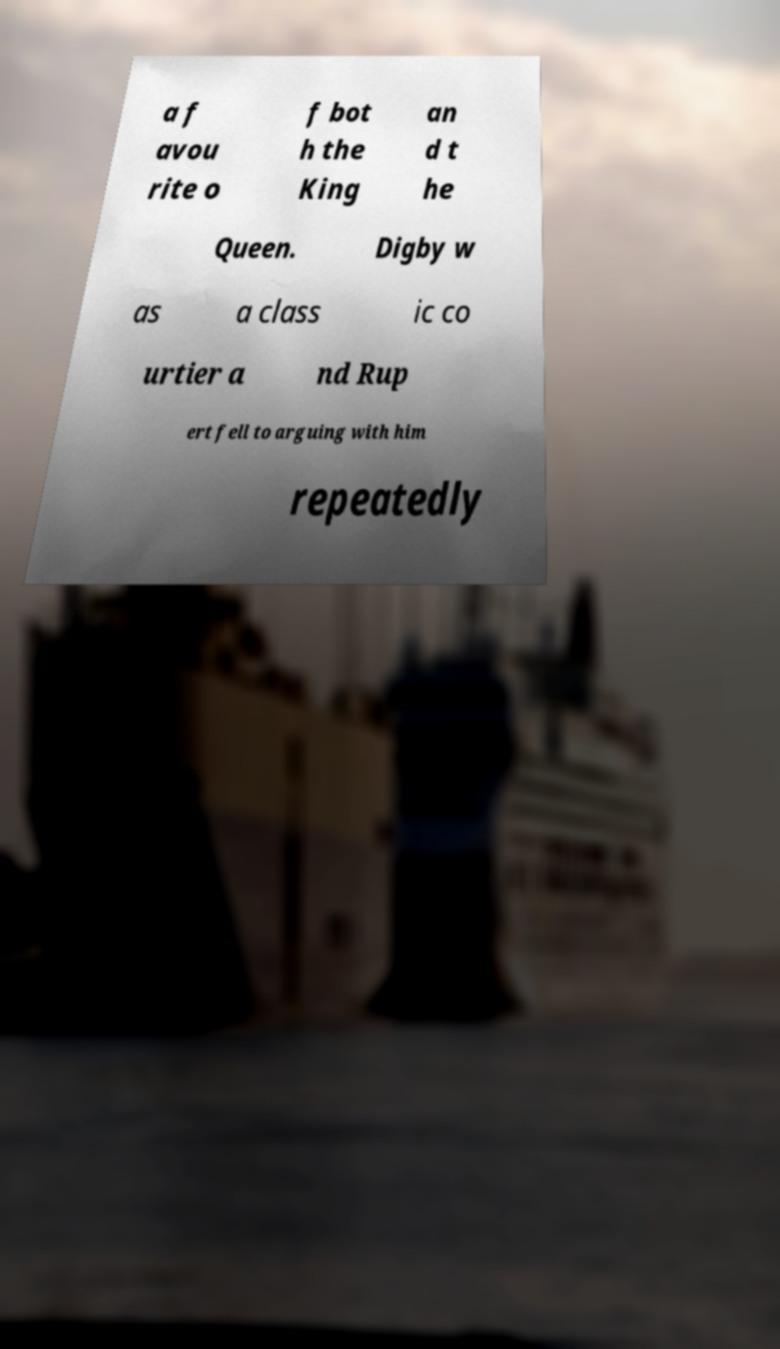For documentation purposes, I need the text within this image transcribed. Could you provide that? a f avou rite o f bot h the King an d t he Queen. Digby w as a class ic co urtier a nd Rup ert fell to arguing with him repeatedly 